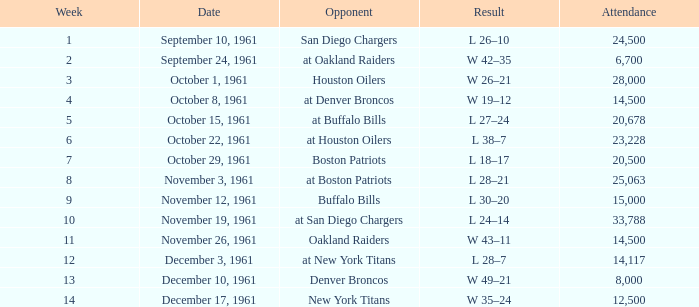What is the low week from october 15, 1961? 5.0. 